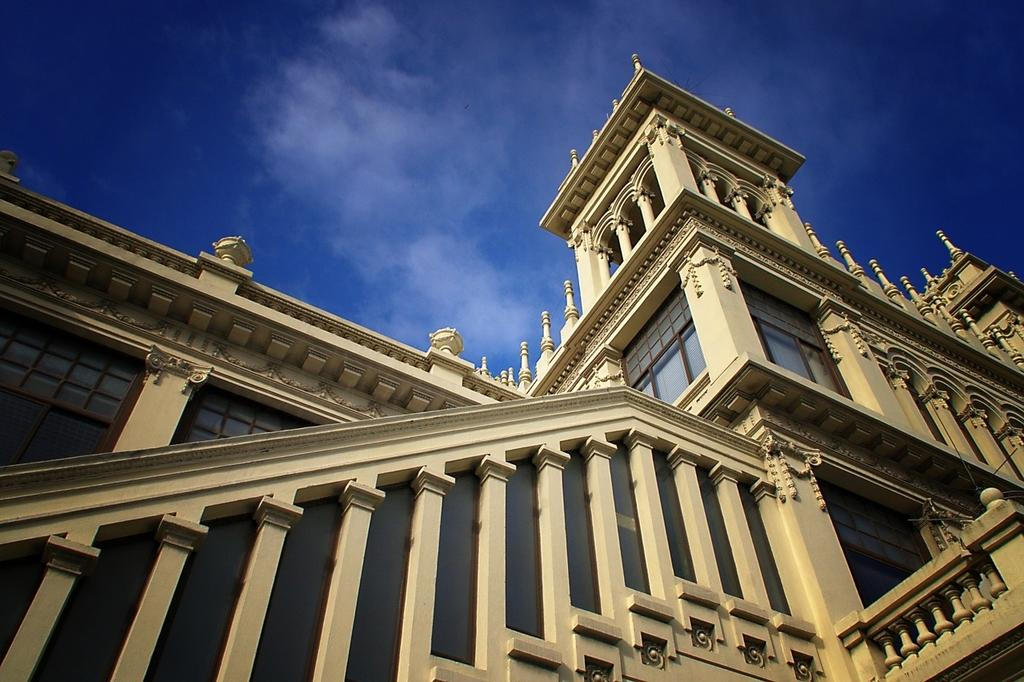What type of structure is present in the image? There is a building in the image. What part of the natural environment is visible in the image? The sky is visible at the top of the image. Where is the beggar located in the image? There is no beggar present in the image. What is the central focus of the image? The central focus of the image cannot be determined from the provided facts, as only the presence of a building and the sky are mentioned. 